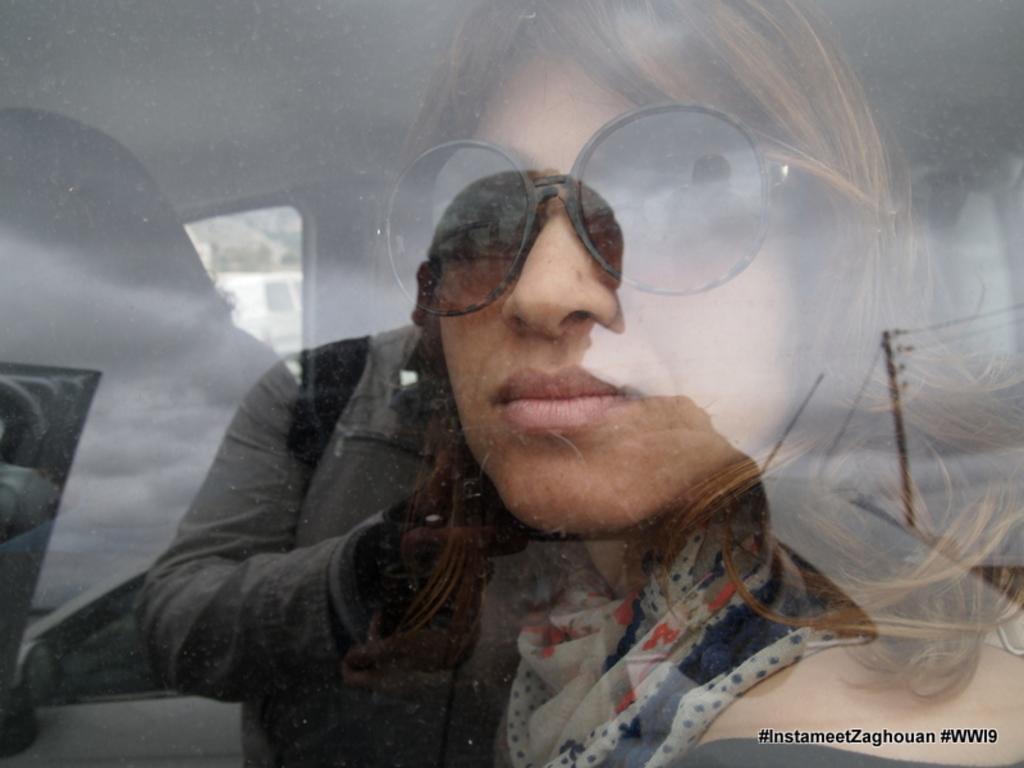How would you summarize this image in a sentence or two? In this image we can see people sitting in the vehicle and we can see a reflection of a man holding a camera on the window glass. 